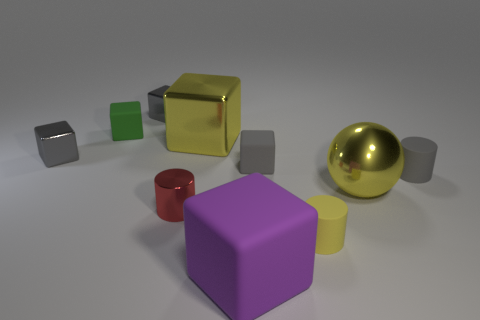Subtract all yellow balls. How many gray cubes are left? 3 Subtract all purple blocks. How many blocks are left? 5 Subtract all gray metallic cubes. How many cubes are left? 4 Subtract all yellow cubes. Subtract all gray cylinders. How many cubes are left? 5 Subtract all cylinders. How many objects are left? 7 Add 5 cyan blocks. How many cyan blocks exist? 5 Subtract 0 cyan cylinders. How many objects are left? 10 Subtract all green rubber cubes. Subtract all big matte cubes. How many objects are left? 8 Add 3 tiny red metallic things. How many tiny red metallic things are left? 4 